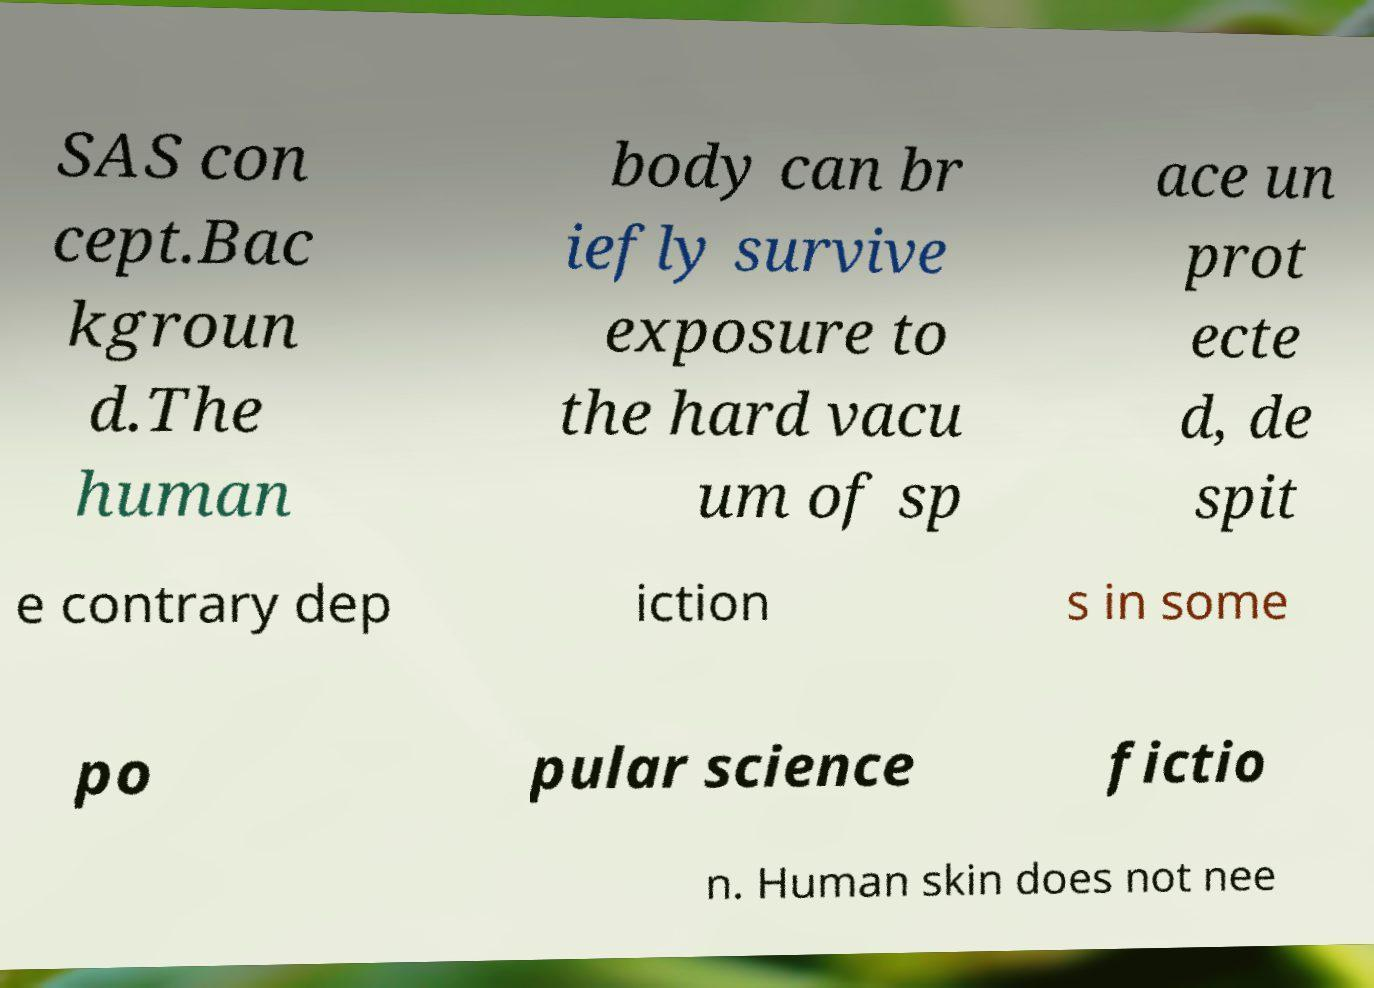Could you assist in decoding the text presented in this image and type it out clearly? SAS con cept.Bac kgroun d.The human body can br iefly survive exposure to the hard vacu um of sp ace un prot ecte d, de spit e contrary dep iction s in some po pular science fictio n. Human skin does not nee 